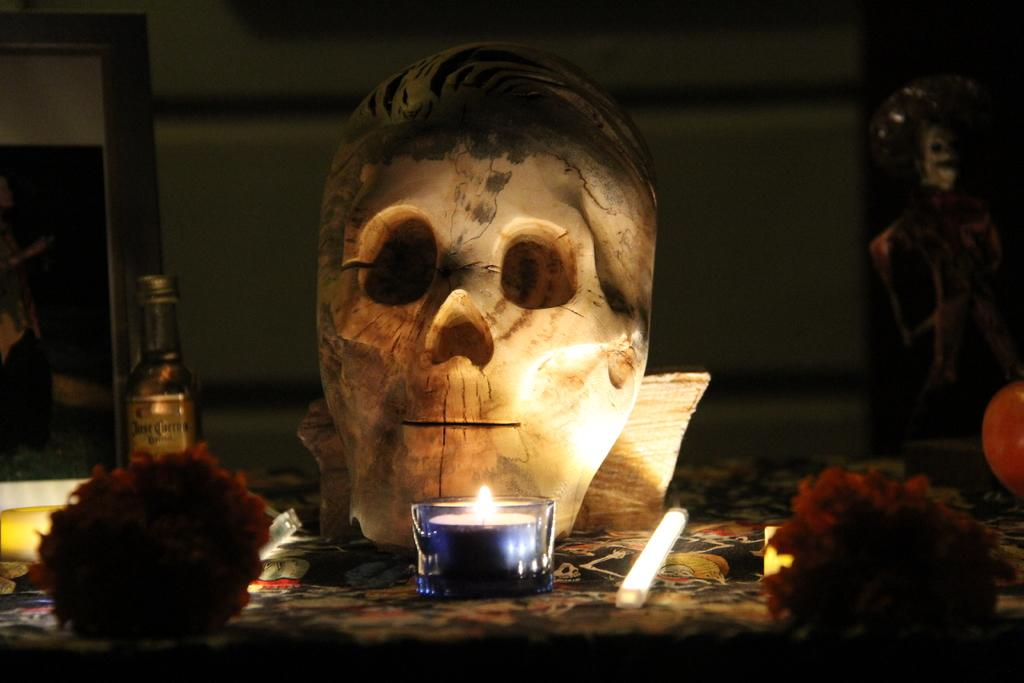What type of mask can be seen in the image? There is a skull mask in the image. What is the source of light in the image? There is a candle and a light in the image. What type of decorative items are present in the image? There are flowers and a photo frame in the image. What type of container is visible in the image? There is a bottle in the image. What other objects can be seen on the surface in the image? There are other objects on the surface in the image, but their specific details are not mentioned in the facts. What is the color of the background in the image? The background of the image is dark. What type of cord is used to hang the photo frame in the image? There is no mention of a cord or any hanging mechanism for the photo frame in the image. What hobbies does the person in the photo frame enjoy? There is no information about the person in the photo frame or their hobbies in the image. What color is the eye of the skull mask in the image? The facts do not mention any color for the skull mask or its features, including the eye. 